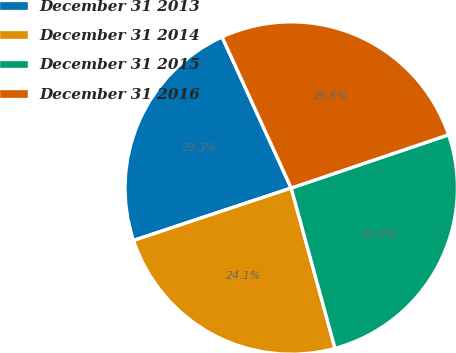Convert chart to OTSL. <chart><loc_0><loc_0><loc_500><loc_500><pie_chart><fcel>December 31 2013<fcel>December 31 2014<fcel>December 31 2015<fcel>December 31 2016<nl><fcel>23.28%<fcel>24.14%<fcel>25.95%<fcel>26.64%<nl></chart> 